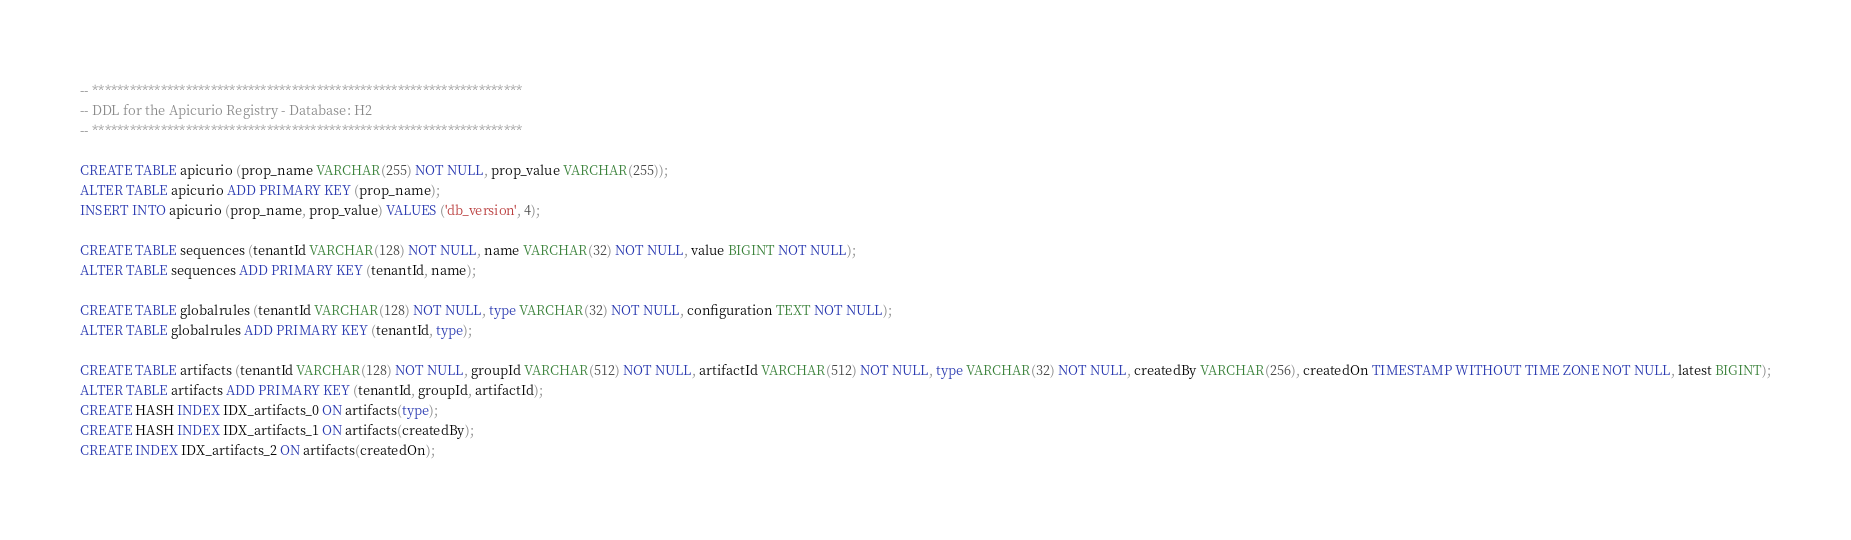Convert code to text. <code><loc_0><loc_0><loc_500><loc_500><_SQL_>-- *********************************************************************
-- DDL for the Apicurio Registry - Database: H2
-- *********************************************************************

CREATE TABLE apicurio (prop_name VARCHAR(255) NOT NULL, prop_value VARCHAR(255));
ALTER TABLE apicurio ADD PRIMARY KEY (prop_name);
INSERT INTO apicurio (prop_name, prop_value) VALUES ('db_version', 4);

CREATE TABLE sequences (tenantId VARCHAR(128) NOT NULL, name VARCHAR(32) NOT NULL, value BIGINT NOT NULL);
ALTER TABLE sequences ADD PRIMARY KEY (tenantId, name);

CREATE TABLE globalrules (tenantId VARCHAR(128) NOT NULL, type VARCHAR(32) NOT NULL, configuration TEXT NOT NULL);
ALTER TABLE globalrules ADD PRIMARY KEY (tenantId, type);

CREATE TABLE artifacts (tenantId VARCHAR(128) NOT NULL, groupId VARCHAR(512) NOT NULL, artifactId VARCHAR(512) NOT NULL, type VARCHAR(32) NOT NULL, createdBy VARCHAR(256), createdOn TIMESTAMP WITHOUT TIME ZONE NOT NULL, latest BIGINT);
ALTER TABLE artifacts ADD PRIMARY KEY (tenantId, groupId, artifactId);
CREATE HASH INDEX IDX_artifacts_0 ON artifacts(type);
CREATE HASH INDEX IDX_artifacts_1 ON artifacts(createdBy);
CREATE INDEX IDX_artifacts_2 ON artifacts(createdOn);
</code> 